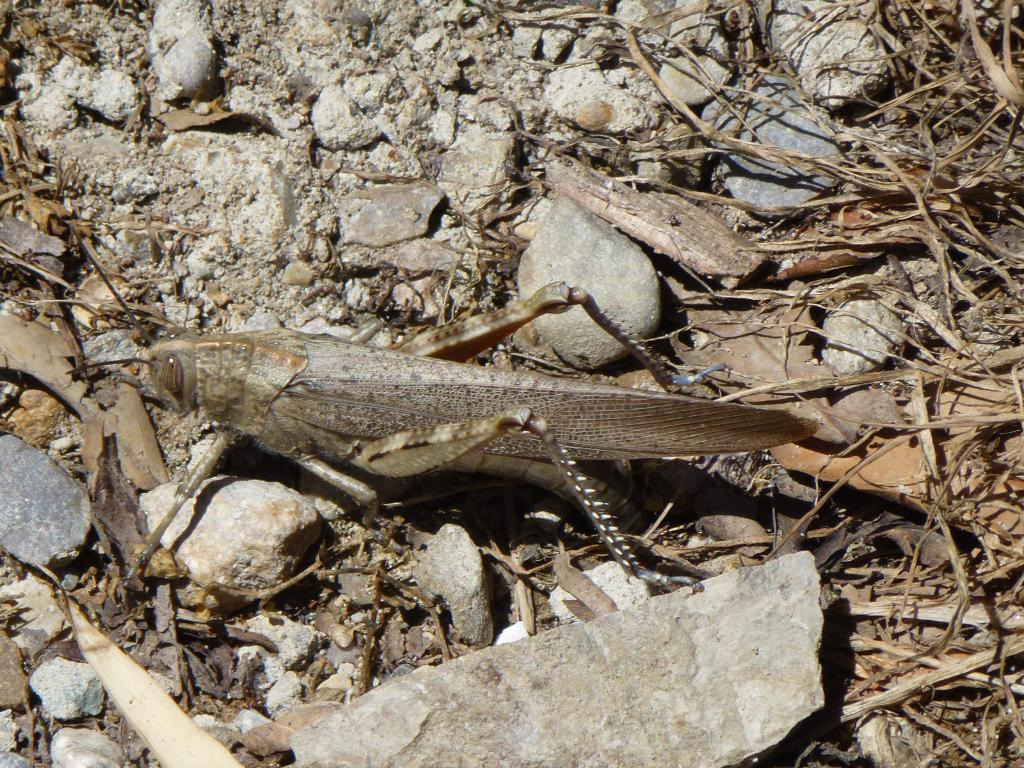What type of insect can be seen in the image? There is a fly in the image. Where is the fly located? The fly is on the land. What other objects can be found on the land in the image? There are stones, rocks, and dry stems present on the land. What type of toothbrush is being used to play volleyball in the image? There is no toothbrush or volleyball present in the image. 